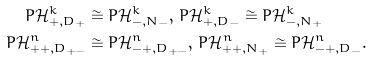<formula> <loc_0><loc_0><loc_500><loc_500>P \mathcal { H } ^ { k } _ { + , D _ { + } } & \cong P \mathcal { H } ^ { k } _ { - , N _ { - } } , \, P \mathcal { H } ^ { k } _ { + , D _ { - } } \cong P \mathcal { H } ^ { k } _ { - , N _ { + } } \\ P \mathcal { H } ^ { n } _ { + + , D _ { + - } } & \cong P \mathcal { H } ^ { n } _ { - + , D _ { + - } } , \, P \mathcal { H } ^ { n } _ { + + , N _ { + } } \cong P \mathcal { H } ^ { n } _ { - + , D _ { - } } .</formula> 